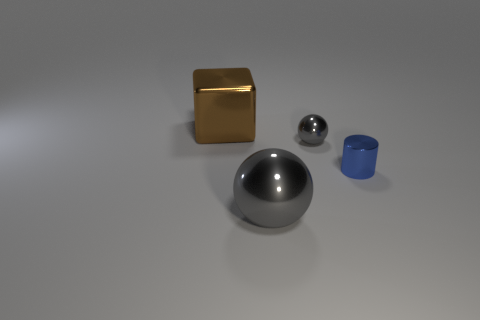The other gray shiny thing that is the same shape as the large gray shiny thing is what size?
Your response must be concise. Small. What number of gray metallic spheres are in front of the big metallic thing that is to the right of the big shiny cube to the left of the small gray shiny ball?
Offer a terse response. 0. Is there anything else that has the same size as the shiny cube?
Offer a terse response. Yes. What is the shape of the big shiny thing that is in front of the big brown metallic object that is on the left side of the large object in front of the brown cube?
Make the answer very short. Sphere. How many other things are the same color as the cylinder?
Your response must be concise. 0. There is a thing that is behind the small object to the left of the blue object; what is its shape?
Give a very brief answer. Cube. What number of metallic spheres are behind the big gray ball?
Make the answer very short. 1. Are there any cyan cubes made of the same material as the tiny gray object?
Ensure brevity in your answer.  No. What material is the gray ball that is the same size as the blue shiny thing?
Offer a terse response. Metal. There is a object that is both in front of the small gray metallic object and behind the big gray shiny object; what is its size?
Provide a succinct answer. Small. 